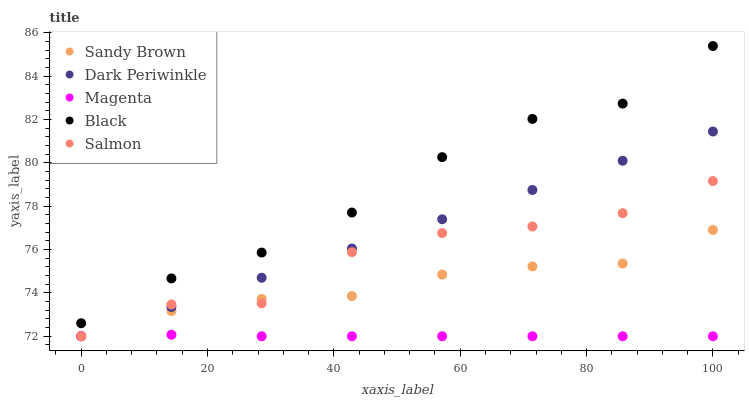Does Magenta have the minimum area under the curve?
Answer yes or no. Yes. Does Black have the maximum area under the curve?
Answer yes or no. Yes. Does Sandy Brown have the minimum area under the curve?
Answer yes or no. No. Does Sandy Brown have the maximum area under the curve?
Answer yes or no. No. Is Dark Periwinkle the smoothest?
Answer yes or no. Yes. Is Salmon the roughest?
Answer yes or no. Yes. Is Magenta the smoothest?
Answer yes or no. No. Is Magenta the roughest?
Answer yes or no. No. Does Magenta have the lowest value?
Answer yes or no. Yes. Does Black have the highest value?
Answer yes or no. Yes. Does Sandy Brown have the highest value?
Answer yes or no. No. Is Magenta less than Black?
Answer yes or no. Yes. Is Black greater than Salmon?
Answer yes or no. Yes. Does Sandy Brown intersect Salmon?
Answer yes or no. Yes. Is Sandy Brown less than Salmon?
Answer yes or no. No. Is Sandy Brown greater than Salmon?
Answer yes or no. No. Does Magenta intersect Black?
Answer yes or no. No. 